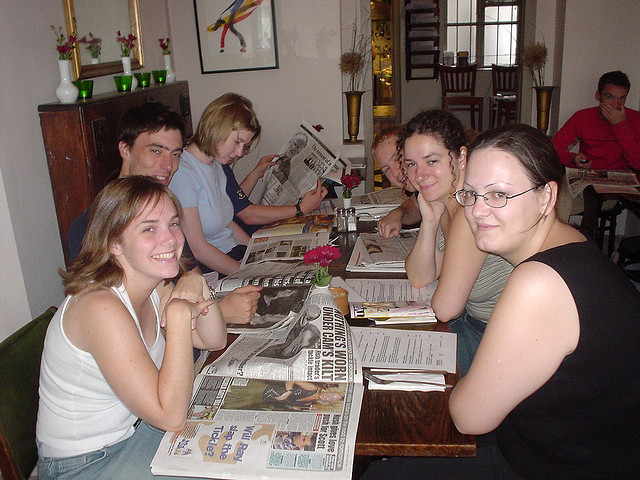How many dogs are sitting down? There are no dogs present in the image. The image shows a group of people sitting at a table with newspapers and menus, possibly at a cafe or restaurant. 